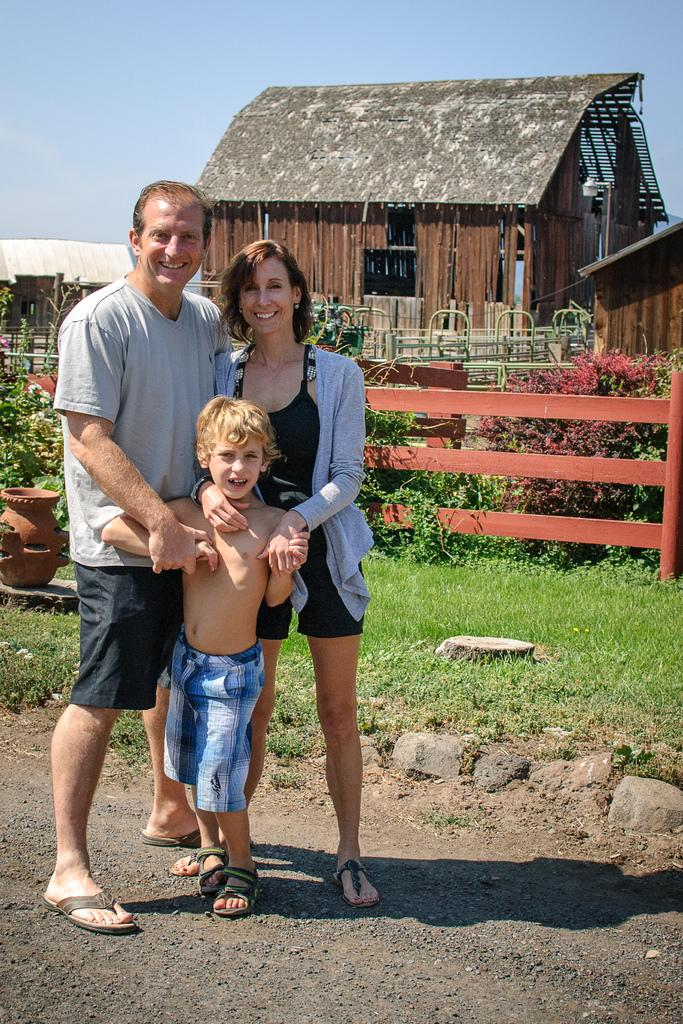How many people are present in the image? There is a man, a woman, and a boy standing in the image, making a total of three people. What can be seen in the background of the image? There is a wooden fence, plants, pots, and a building in the background of the image. What is the condition of the sky in the image? The sky is clear in the image. What type of band is performing in the image? There is no band present in the image; it features a man, a woman, and a boy standing in front of a wooden fence, plants, pots, and a building. Is the image taken during winter, given the presence of snow or cold weather? The image does not show any snow or cold weather, and the sky is clear, so it cannot be determined if the image was taken during winter. 